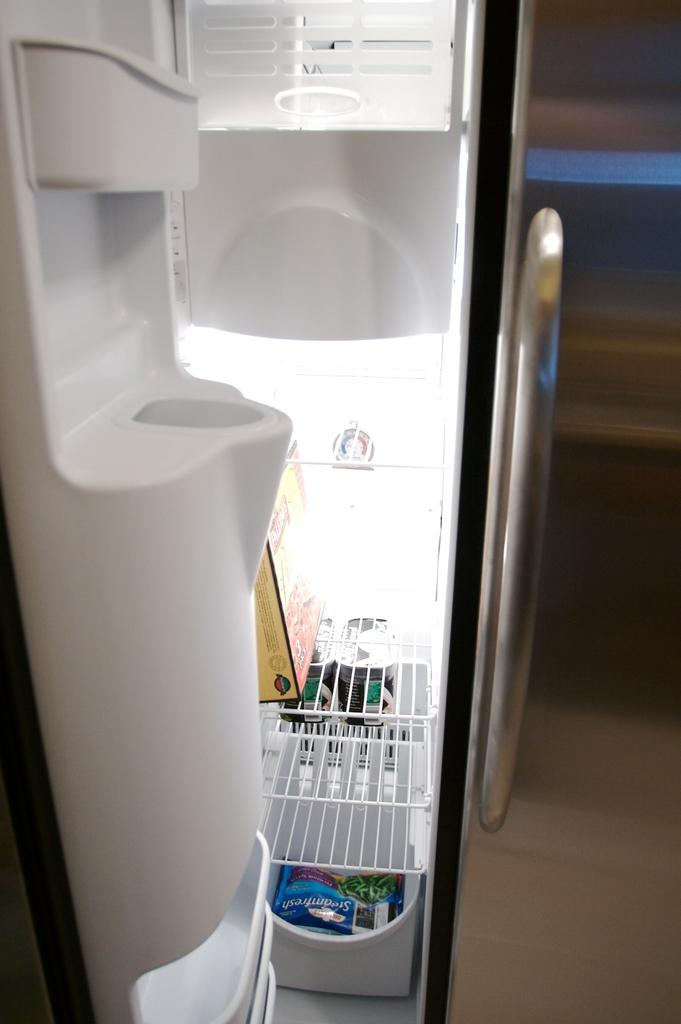<image>
Share a concise interpretation of the image provided. A near empty freezer has a bag of SteamFresh green beans on the bottom shelf 